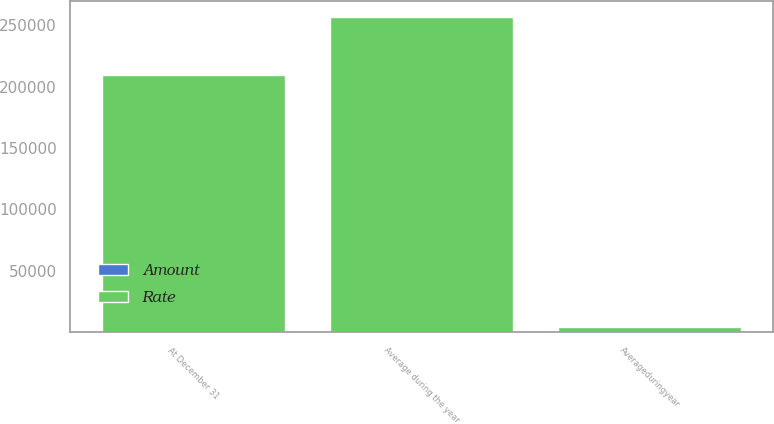<chart> <loc_0><loc_0><loc_500><loc_500><stacked_bar_chart><ecel><fcel>At December 31<fcel>Average during the year<fcel>Averageduringyear<nl><fcel>Rate<fcel>209616<fcel>256943<fcel>4718<nl><fcel>Amount<fcel>0.85<fcel>0.71<fcel>0.15<nl></chart> 